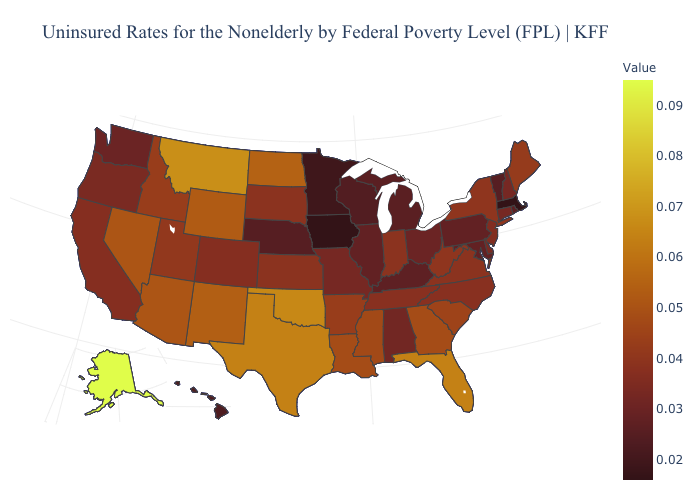Which states have the lowest value in the USA?
Concise answer only. Iowa, Massachusetts. Does Massachusetts have the lowest value in the USA?
Give a very brief answer. Yes. Which states have the highest value in the USA?
Keep it brief. Alaska. 